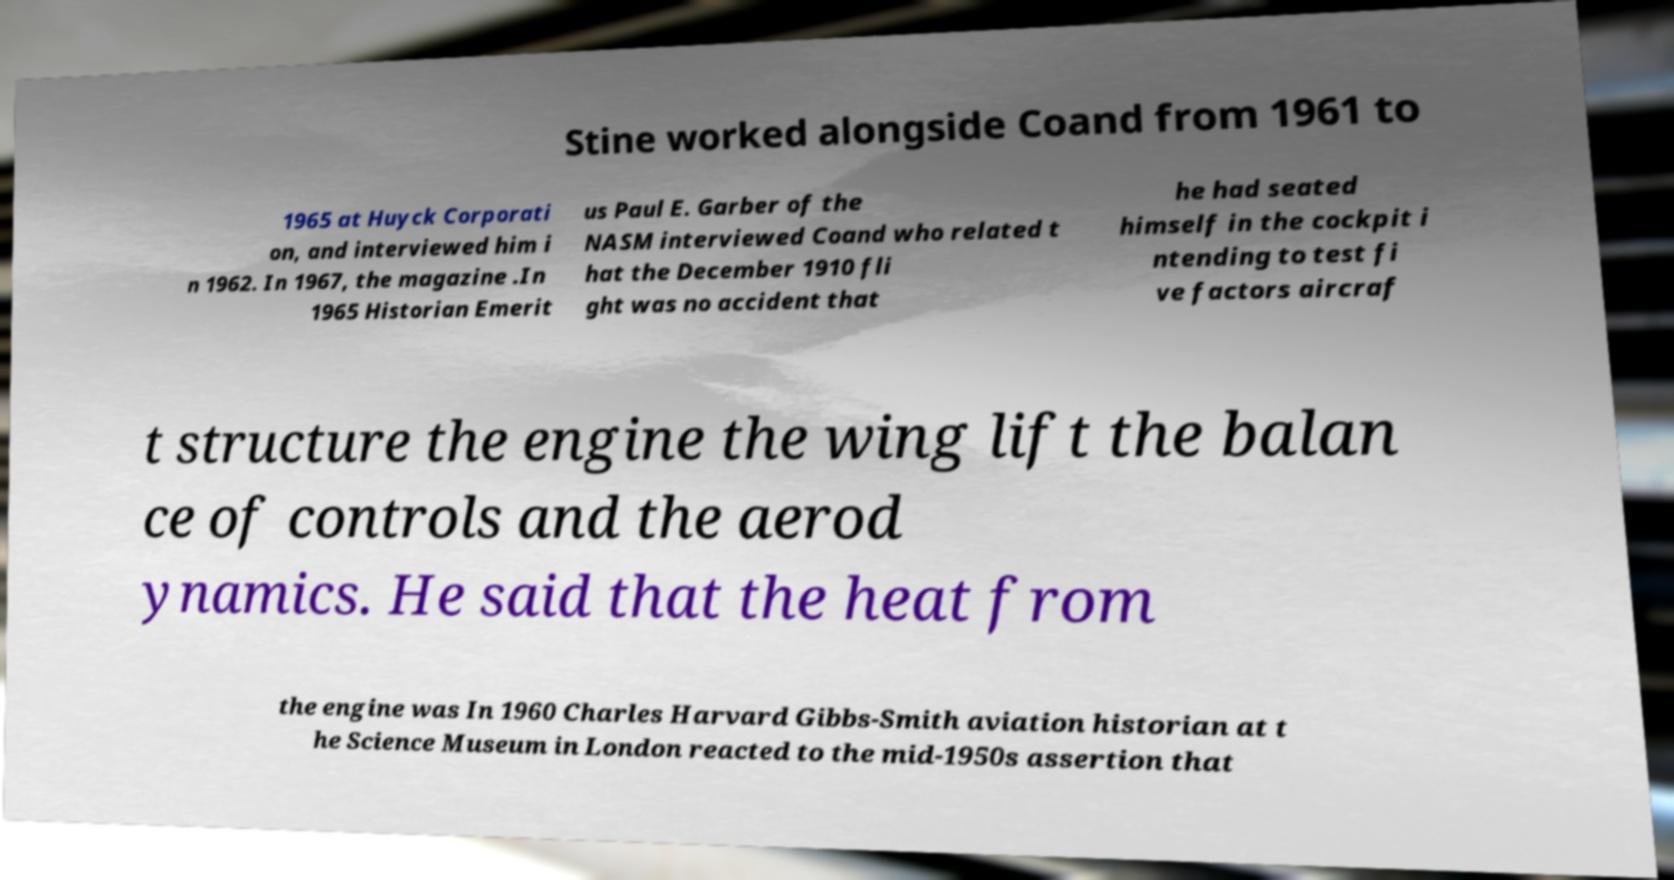For documentation purposes, I need the text within this image transcribed. Could you provide that? Stine worked alongside Coand from 1961 to 1965 at Huyck Corporati on, and interviewed him i n 1962. In 1967, the magazine .In 1965 Historian Emerit us Paul E. Garber of the NASM interviewed Coand who related t hat the December 1910 fli ght was no accident that he had seated himself in the cockpit i ntending to test fi ve factors aircraf t structure the engine the wing lift the balan ce of controls and the aerod ynamics. He said that the heat from the engine was In 1960 Charles Harvard Gibbs-Smith aviation historian at t he Science Museum in London reacted to the mid-1950s assertion that 